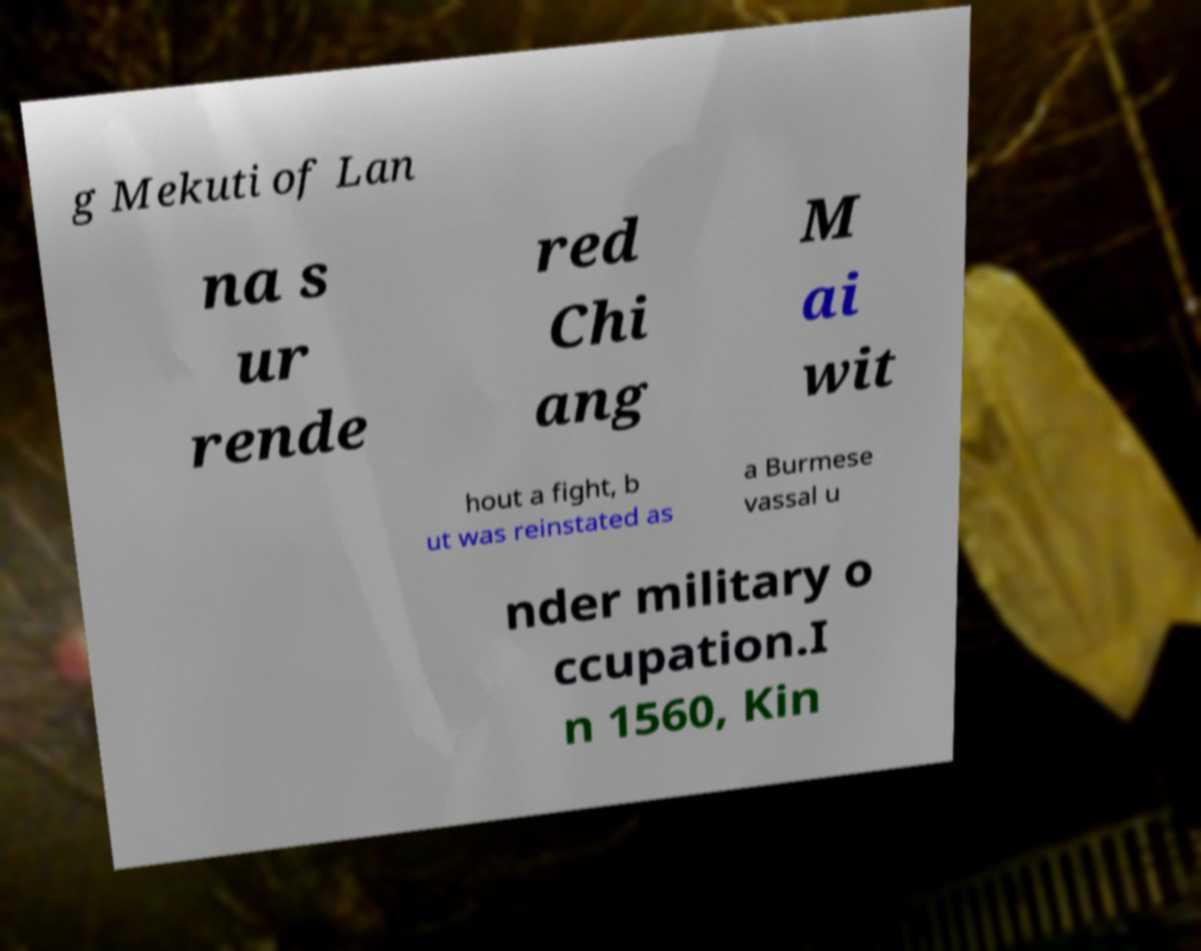I need the written content from this picture converted into text. Can you do that? g Mekuti of Lan na s ur rende red Chi ang M ai wit hout a fight, b ut was reinstated as a Burmese vassal u nder military o ccupation.I n 1560, Kin 